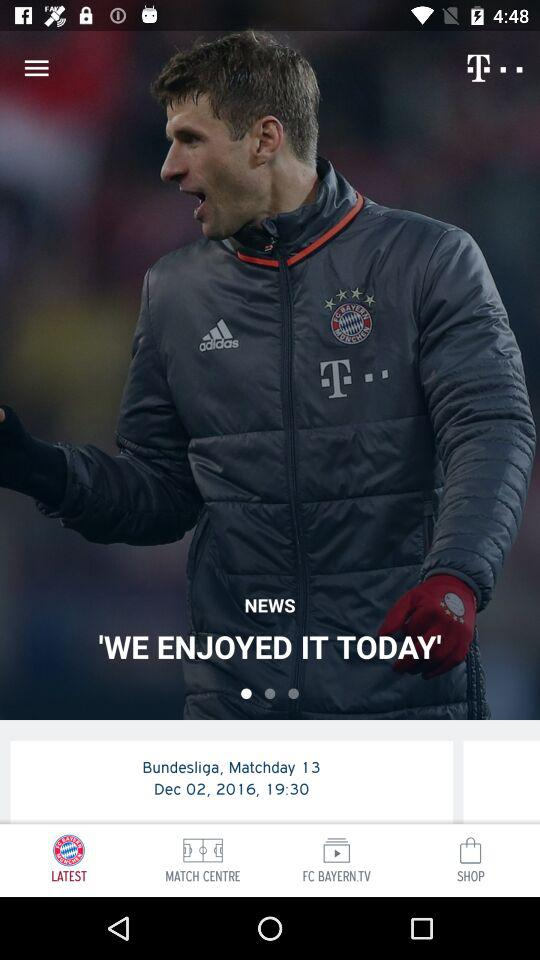When did the match take place? The match took place on December 2, 2016 at 19:30. 